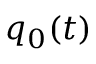Convert formula to latex. <formula><loc_0><loc_0><loc_500><loc_500>q _ { 0 } ( t )</formula> 